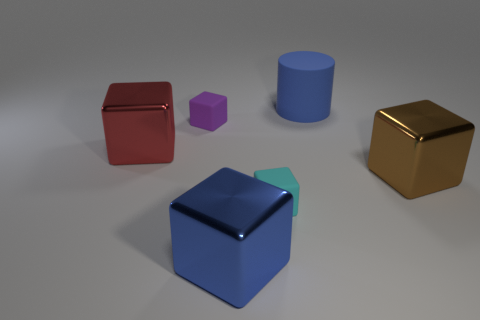How many objects are blocks right of the blue cylinder or cubes in front of the red cube?
Keep it short and to the point. 3. What is the material of the red object that is the same size as the blue shiny cube?
Provide a succinct answer. Metal. There is a small rubber object in front of the big brown metal block; does it have the same shape as the big thing that is right of the big blue rubber thing?
Ensure brevity in your answer.  Yes. There is a large metallic cube that is on the right side of the rubber cube in front of the big metal cube to the right of the cylinder; what color is it?
Provide a succinct answer. Brown. What number of other objects are there of the same color as the matte cylinder?
Offer a very short reply. 1. Is the number of blue matte things less than the number of small yellow metal blocks?
Your answer should be compact. No. What is the color of the metal thing that is both right of the large red block and behind the big blue cube?
Make the answer very short. Brown. There is a large red thing that is the same shape as the blue metallic object; what is it made of?
Offer a terse response. Metal. Are there more large green objects than blue objects?
Your answer should be compact. No. There is a block that is both on the left side of the big blue metallic thing and right of the red cube; how big is it?
Provide a short and direct response. Small. 